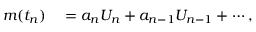<formula> <loc_0><loc_0><loc_500><loc_500>\begin{array} { r l } { m ( t _ { n } ) } & = a _ { n } U _ { n } + a _ { n - 1 } U _ { n - 1 } + \cdots , } \end{array}</formula> 